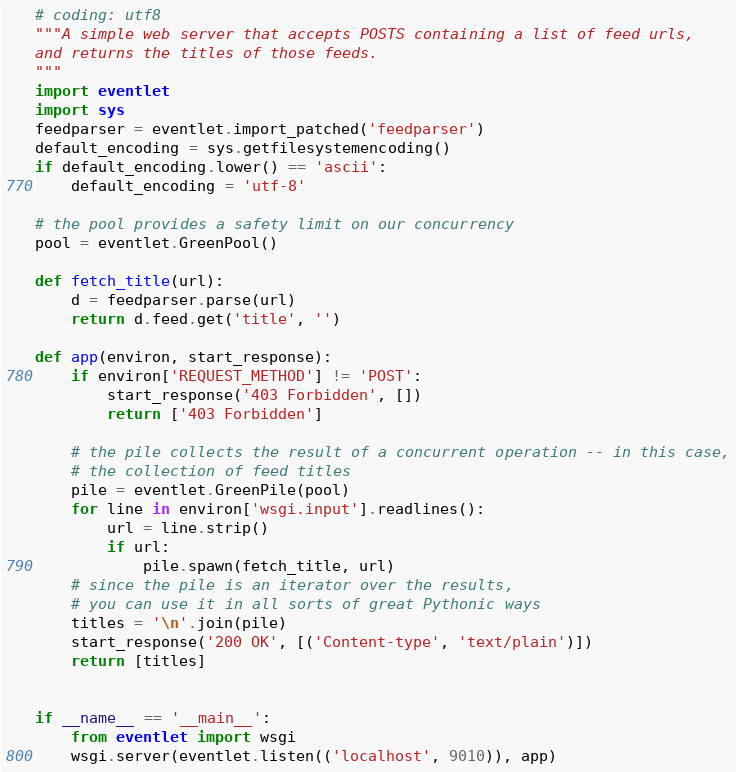Convert code to text. <code><loc_0><loc_0><loc_500><loc_500><_Python_># coding: utf8
"""A simple web server that accepts POSTS containing a list of feed urls,
and returns the titles of those feeds.
"""
import eventlet
import sys
feedparser = eventlet.import_patched('feedparser')
default_encoding = sys.getfilesystemencoding()
if default_encoding.lower() == 'ascii':       
    default_encoding = 'utf-8'            

# the pool provides a safety limit on our concurrency
pool = eventlet.GreenPool()

def fetch_title(url):
    d = feedparser.parse(url)
    return d.feed.get('title', '')

def app(environ, start_response):
    if environ['REQUEST_METHOD'] != 'POST':
        start_response('403 Forbidden', [])
        return ['403 Forbidden']
    
    # the pile collects the result of a concurrent operation -- in this case,
    # the collection of feed titles
    pile = eventlet.GreenPile(pool)
    for line in environ['wsgi.input'].readlines():
        url = line.strip()
        if url:
            pile.spawn(fetch_title, url)
    # since the pile is an iterator over the results, 
    # you can use it in all sorts of great Pythonic ways
    titles = '\n'.join(pile)
    start_response('200 OK', [('Content-type', 'text/plain')])
    return [titles]


if __name__ == '__main__':
    from eventlet import wsgi
    wsgi.server(eventlet.listen(('localhost', 9010)), app)
</code> 